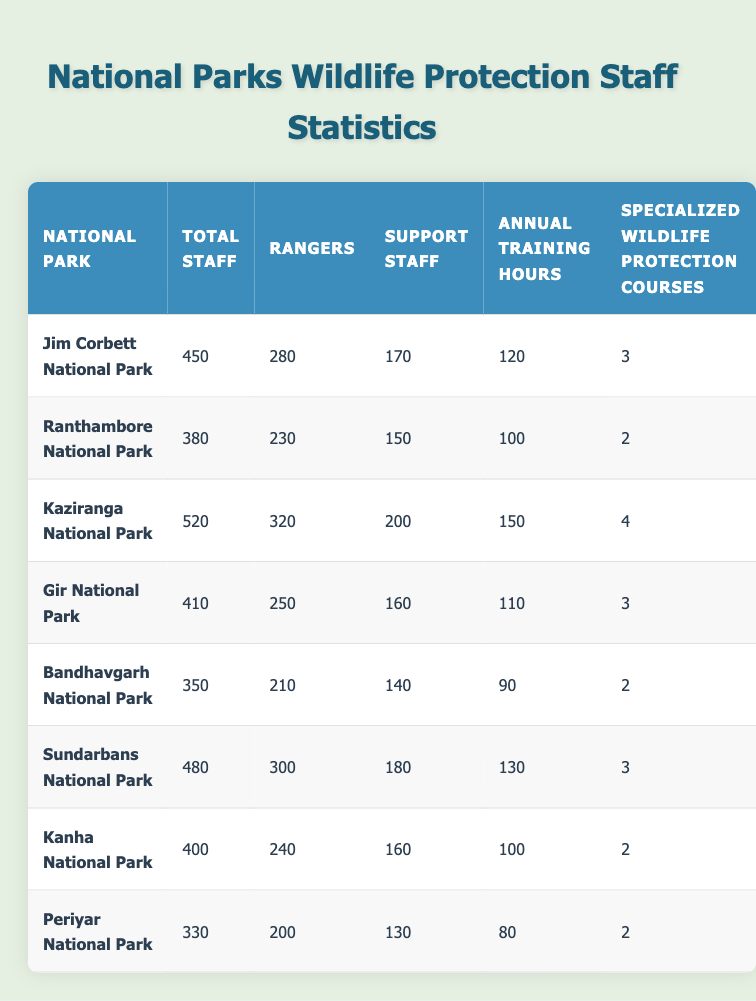What is the total number of staff in Kaziranga National Park? The table lists Kaziranga National Park with a total staff count of 520. This information is found in the second column of the corresponding row for Kaziranga National Park.
Answer: 520 How many rangers are employed at Jim Corbett National Park? In the table, the number of rangers at Jim Corbett National Park is shown as 280, which is found in the third column of the respective row.
Answer: 280 Which national park has the highest number of specialized wildlife protection courses? By inspecting the table, Kaziranga National Park has 4 specialized wildlife protection courses, which is the maximum value in the last column.
Answer: Kaziranga National Park What is the average number of annual training hours across all parks? To find the average, sum the annual training hours: (120 + 100 + 150 + 110 + 90 + 130 + 100 + 80) = 980. There are 8 parks, so divide 980 by 8, which equals 122.5.
Answer: 122.5 Is it true that Gir National Park has more support staff than Ranthambore National Park? From the table, Gir National Park has 160 support staff while Ranthambore National Park has 150; since 160 is greater than 150, the statement is true.
Answer: Yes How many total staff do the two parks with the fewest staff combined have? The two parks with the fewest staff are Periyar National Park (330) and Bandhavgarh National Park (350). Their total is 330 + 350 = 680.
Answer: 680 Which park has a greater difference between total staff and rangers: Sundarbans National Park or Kanha National Park? Sundarbans National Park has 480 total staff and 300 rangers, giving a difference of 480 - 300 = 180. Kanha National Park has 400 total staff and 240 rangers, resulting in a difference of 400 - 240 = 160. Since 180 > 160, Sundarbans has the greater difference.
Answer: Sundarbans National Park What percentage of total staff at Gir National Park are rangers? Calculate the percentage by taking the number of rangers (250) divided by total staff (410), multiplied by 100. So, (250 / 410) * 100 = 60.98%. Rounding gives approximately 61%.
Answer: 61% Do all national parks have more than 200 rangers? By reviewing the table, Periyar National Park shows only 200 rangers, while others have more than 200. Therefore, not all parks exceed that number, making the statement false.
Answer: No 